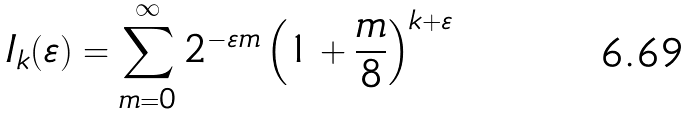Convert formula to latex. <formula><loc_0><loc_0><loc_500><loc_500>I _ { k } ( \varepsilon ) = \sum _ { m = 0 } ^ { \infty } 2 ^ { - \varepsilon m } \left ( 1 + \frac { m } { 8 } \right ) ^ { k + \varepsilon }</formula> 